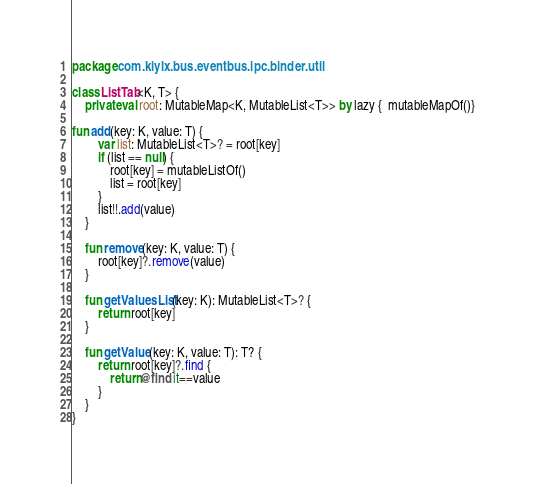Convert code to text. <code><loc_0><loc_0><loc_500><loc_500><_Kotlin_>package com.kiylx.bus.eventbus.ipc.binder.util

class ListTab<K, T> {
    private val root: MutableMap<K, MutableList<T>> by lazy {  mutableMapOf()}

fun add(key: K, value: T) {
        var list: MutableList<T>? = root[key]
        if (list == null) {
            root[key] = mutableListOf()
            list = root[key]
        }
        list!!.add(value)
    }

    fun remove(key: K, value: T) {
        root[key]?.remove(value)
    }

    fun getValuesList(key: K): MutableList<T>? {
        return root[key]
    }

    fun getValue(key: K, value: T): T? {
        return root[key]?.find {
            return@find it==value
        }
    }
}</code> 